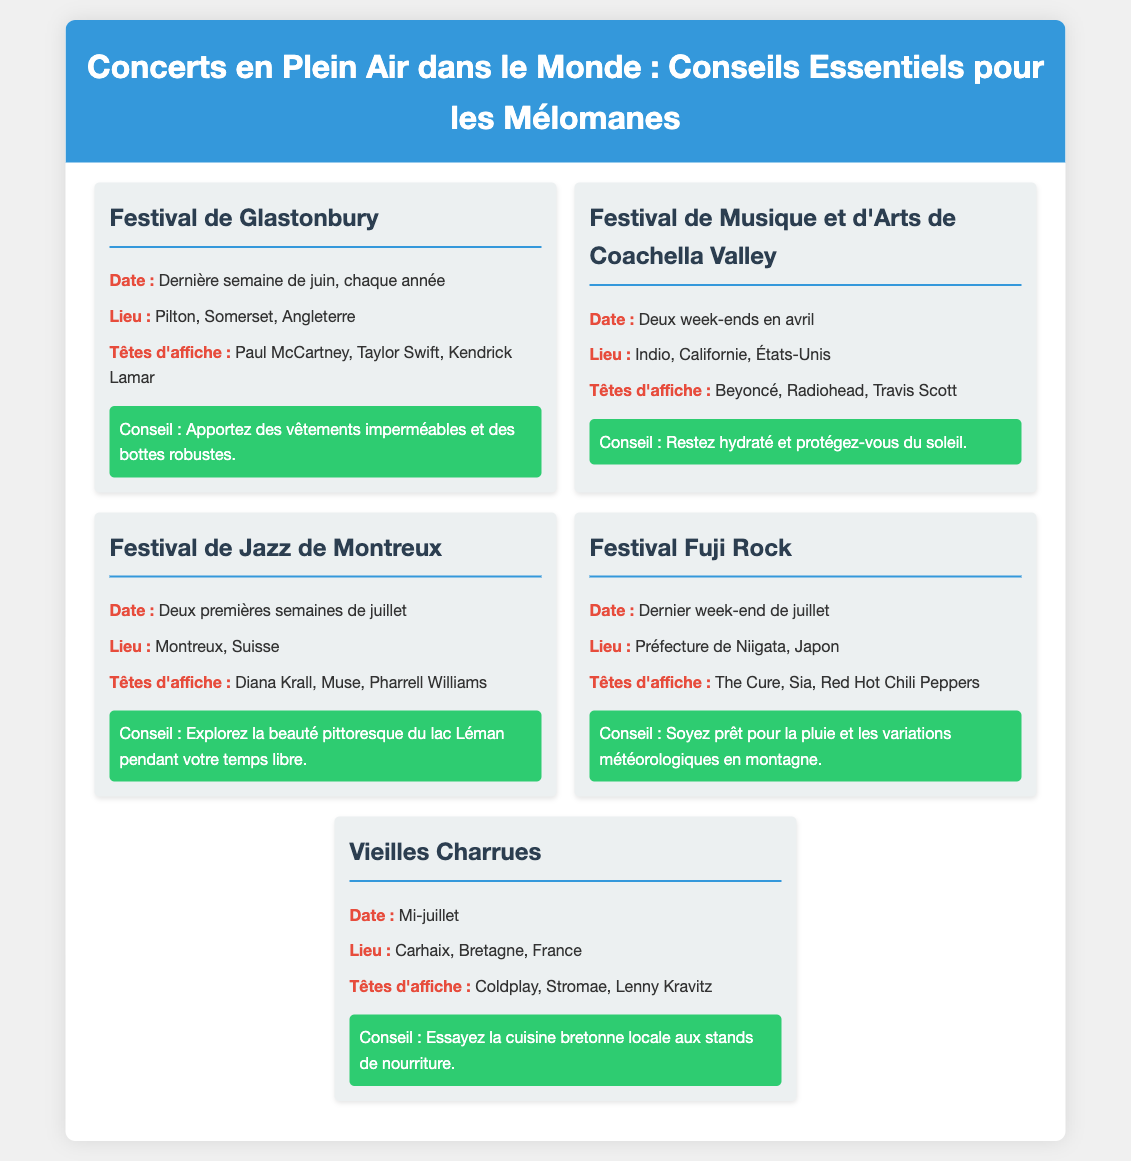Quel est le lieu du Festival de Glastonbury ? Le Festival de Glastonbury se déroule à Pilton, Somerset, Angleterre.
Answer: Pilton, Somerset, Angleterre Quel est le mois des festivals Coachella ? Le Festival de Musique et d'Arts de Coachella Valley se déroule en avril.
Answer: Avril Combien de temps dure le Festival de Jazz de Montreux ? Le Festival de Jazz de Montreux a lieu pendant deux semaines.
Answer: Deux semaines Quels artistes sont têtes d'affiche au Festival Fuji Rock ? Les têtes d'affiche incluent The Cure, Sia, Red Hot Chili Peppers.
Answer: The Cure, Sia, Red Hot Chili Peppers Quelle est une recommandation pour le Festival de Musique et d'Arts de Coachella Valley ? Il est conseillé de rester hydraté et de se protéger du soleil.
Answer: Restez hydraté et protégez-vous du soleil Quels types de cuisine peut-on essayer au festival Vieilles Charrues ? On peut essayer la cuisine bretonne locale aux stands de nourriture.
Answer: Cuisine bretonne locale Quel est le nom d'un artiste qui se produira à Glastonbury ? Paul McCartney est l'un des artistes têtes d'affiche au Festival de Glastonbury.
Answer: Paul McCartney 